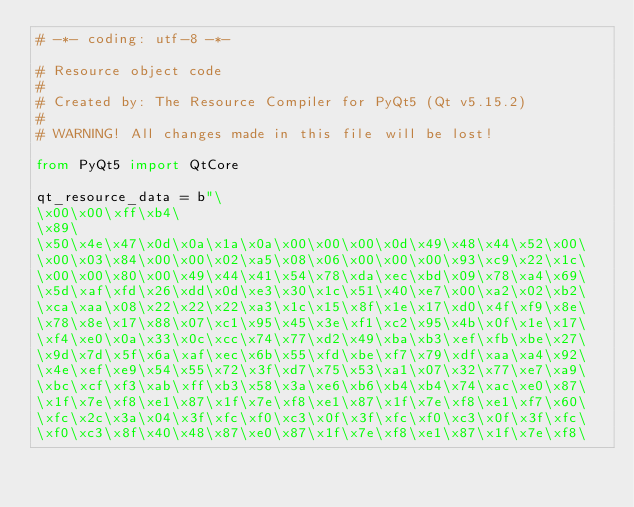<code> <loc_0><loc_0><loc_500><loc_500><_Python_># -*- coding: utf-8 -*-

# Resource object code
#
# Created by: The Resource Compiler for PyQt5 (Qt v5.15.2)
#
# WARNING! All changes made in this file will be lost!

from PyQt5 import QtCore

qt_resource_data = b"\
\x00\x00\xff\xb4\
\x89\
\x50\x4e\x47\x0d\x0a\x1a\x0a\x00\x00\x00\x0d\x49\x48\x44\x52\x00\
\x00\x03\x84\x00\x00\x02\xa5\x08\x06\x00\x00\x00\x93\xc9\x22\x1c\
\x00\x00\x80\x00\x49\x44\x41\x54\x78\xda\xec\xbd\x09\x78\xa4\x69\
\x5d\xaf\xfd\x26\xdd\x0d\xe3\x30\x1c\x51\x40\xe7\x00\xa2\x02\xb2\
\xca\xaa\x08\x22\x22\x22\xa3\x1c\x15\x8f\x1e\x17\xd0\x4f\xf9\x8e\
\x78\x8e\x17\x88\x07\xc1\x95\x45\x3e\xf1\xc2\x95\x4b\x0f\x1e\x17\
\xf4\xe0\x0a\x33\x0c\xcc\x74\x77\xd2\x49\xba\xb3\xef\xfb\xbe\x27\
\x9d\x7d\x5f\x6a\xaf\xec\x6b\x55\xfd\xbe\xf7\x79\xdf\xaa\xa4\x92\
\x4e\xef\xe9\x54\x55\x72\x3f\xd7\x75\x53\xa1\x07\x32\x77\xe7\xa9\
\xbc\xcf\xf3\xab\xff\xb3\x58\x3a\xe6\xb6\xb4\xb4\x74\xac\xe0\x87\
\x1f\x7e\xf8\xe1\x87\x1f\x7e\xf8\xe1\x87\x1f\x7e\xf8\xe1\xf7\x60\
\xfc\x2c\x3a\x04\x3f\xfc\xf0\xc3\x0f\x3f\xfc\xf0\xc3\x0f\x3f\xfc\
\xf0\xc3\x8f\x40\x48\x87\xe0\x87\x1f\x7e\xf8\xe1\x87\x1f\x7e\xf8\</code> 